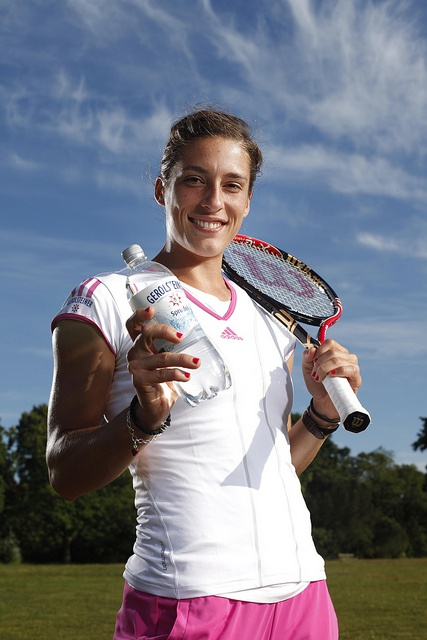Describe the objects in this image and their specific colors. I can see people in gray, white, black, darkgray, and maroon tones, tennis racket in gray, darkgray, black, and lightgray tones, and bottle in gray, white, and darkgray tones in this image. 